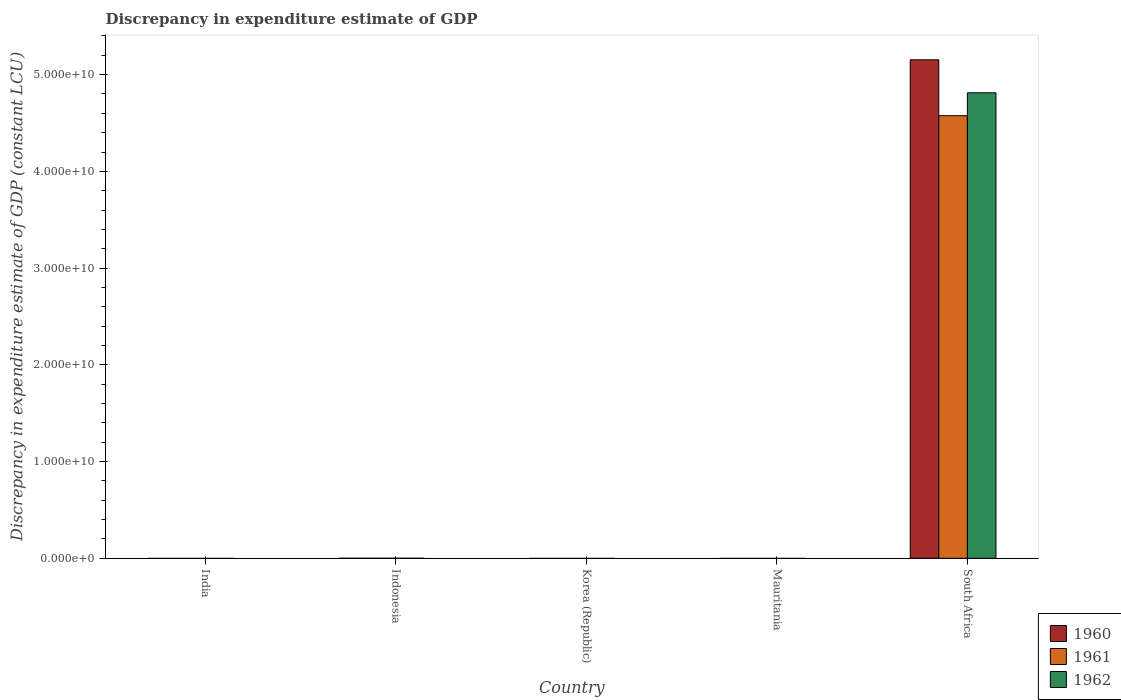Are the number of bars per tick equal to the number of legend labels?
Offer a terse response. No. How many bars are there on the 5th tick from the right?
Ensure brevity in your answer.  0. What is the label of the 1st group of bars from the left?
Your answer should be compact. India. In how many cases, is the number of bars for a given country not equal to the number of legend labels?
Your answer should be very brief. 4. What is the discrepancy in expenditure estimate of GDP in 1962 in India?
Offer a terse response. 0. Across all countries, what is the maximum discrepancy in expenditure estimate of GDP in 1962?
Offer a very short reply. 4.81e+1. Across all countries, what is the minimum discrepancy in expenditure estimate of GDP in 1960?
Provide a succinct answer. 0. In which country was the discrepancy in expenditure estimate of GDP in 1962 maximum?
Your answer should be very brief. South Africa. What is the total discrepancy in expenditure estimate of GDP in 1961 in the graph?
Offer a terse response. 4.58e+1. What is the average discrepancy in expenditure estimate of GDP in 1962 per country?
Offer a very short reply. 9.62e+09. What is the difference between the discrepancy in expenditure estimate of GDP of/in 1962 and discrepancy in expenditure estimate of GDP of/in 1960 in South Africa?
Keep it short and to the point. -3.41e+09. In how many countries, is the discrepancy in expenditure estimate of GDP in 1961 greater than 42000000000 LCU?
Provide a short and direct response. 1. What is the difference between the highest and the lowest discrepancy in expenditure estimate of GDP in 1960?
Offer a terse response. 5.15e+1. In how many countries, is the discrepancy in expenditure estimate of GDP in 1960 greater than the average discrepancy in expenditure estimate of GDP in 1960 taken over all countries?
Keep it short and to the point. 1. Is it the case that in every country, the sum of the discrepancy in expenditure estimate of GDP in 1962 and discrepancy in expenditure estimate of GDP in 1961 is greater than the discrepancy in expenditure estimate of GDP in 1960?
Ensure brevity in your answer.  No. How many countries are there in the graph?
Give a very brief answer. 5. Are the values on the major ticks of Y-axis written in scientific E-notation?
Provide a short and direct response. Yes. Does the graph contain any zero values?
Provide a short and direct response. Yes. Does the graph contain grids?
Provide a succinct answer. No. How are the legend labels stacked?
Offer a terse response. Vertical. What is the title of the graph?
Your answer should be very brief. Discrepancy in expenditure estimate of GDP. What is the label or title of the Y-axis?
Ensure brevity in your answer.  Discrepancy in expenditure estimate of GDP (constant LCU). What is the Discrepancy in expenditure estimate of GDP (constant LCU) in 1961 in India?
Provide a succinct answer. 0. What is the Discrepancy in expenditure estimate of GDP (constant LCU) of 1962 in India?
Offer a terse response. 0. What is the Discrepancy in expenditure estimate of GDP (constant LCU) in 1960 in Indonesia?
Your answer should be very brief. 0. What is the Discrepancy in expenditure estimate of GDP (constant LCU) of 1962 in Indonesia?
Make the answer very short. 0. What is the Discrepancy in expenditure estimate of GDP (constant LCU) of 1960 in Korea (Republic)?
Ensure brevity in your answer.  0. What is the Discrepancy in expenditure estimate of GDP (constant LCU) in 1961 in Korea (Republic)?
Your answer should be very brief. 0. What is the Discrepancy in expenditure estimate of GDP (constant LCU) of 1960 in Mauritania?
Provide a succinct answer. 0. What is the Discrepancy in expenditure estimate of GDP (constant LCU) of 1960 in South Africa?
Provide a short and direct response. 5.15e+1. What is the Discrepancy in expenditure estimate of GDP (constant LCU) in 1961 in South Africa?
Offer a very short reply. 4.58e+1. What is the Discrepancy in expenditure estimate of GDP (constant LCU) in 1962 in South Africa?
Keep it short and to the point. 4.81e+1. Across all countries, what is the maximum Discrepancy in expenditure estimate of GDP (constant LCU) in 1960?
Provide a short and direct response. 5.15e+1. Across all countries, what is the maximum Discrepancy in expenditure estimate of GDP (constant LCU) in 1961?
Give a very brief answer. 4.58e+1. Across all countries, what is the maximum Discrepancy in expenditure estimate of GDP (constant LCU) in 1962?
Offer a very short reply. 4.81e+1. Across all countries, what is the minimum Discrepancy in expenditure estimate of GDP (constant LCU) of 1962?
Provide a succinct answer. 0. What is the total Discrepancy in expenditure estimate of GDP (constant LCU) of 1960 in the graph?
Your answer should be compact. 5.15e+1. What is the total Discrepancy in expenditure estimate of GDP (constant LCU) of 1961 in the graph?
Make the answer very short. 4.58e+1. What is the total Discrepancy in expenditure estimate of GDP (constant LCU) in 1962 in the graph?
Ensure brevity in your answer.  4.81e+1. What is the average Discrepancy in expenditure estimate of GDP (constant LCU) of 1960 per country?
Your answer should be very brief. 1.03e+1. What is the average Discrepancy in expenditure estimate of GDP (constant LCU) of 1961 per country?
Provide a short and direct response. 9.15e+09. What is the average Discrepancy in expenditure estimate of GDP (constant LCU) in 1962 per country?
Offer a terse response. 9.62e+09. What is the difference between the Discrepancy in expenditure estimate of GDP (constant LCU) of 1960 and Discrepancy in expenditure estimate of GDP (constant LCU) of 1961 in South Africa?
Provide a succinct answer. 5.78e+09. What is the difference between the Discrepancy in expenditure estimate of GDP (constant LCU) of 1960 and Discrepancy in expenditure estimate of GDP (constant LCU) of 1962 in South Africa?
Your response must be concise. 3.41e+09. What is the difference between the Discrepancy in expenditure estimate of GDP (constant LCU) in 1961 and Discrepancy in expenditure estimate of GDP (constant LCU) in 1962 in South Africa?
Provide a short and direct response. -2.37e+09. What is the difference between the highest and the lowest Discrepancy in expenditure estimate of GDP (constant LCU) of 1960?
Keep it short and to the point. 5.15e+1. What is the difference between the highest and the lowest Discrepancy in expenditure estimate of GDP (constant LCU) of 1961?
Give a very brief answer. 4.58e+1. What is the difference between the highest and the lowest Discrepancy in expenditure estimate of GDP (constant LCU) of 1962?
Make the answer very short. 4.81e+1. 